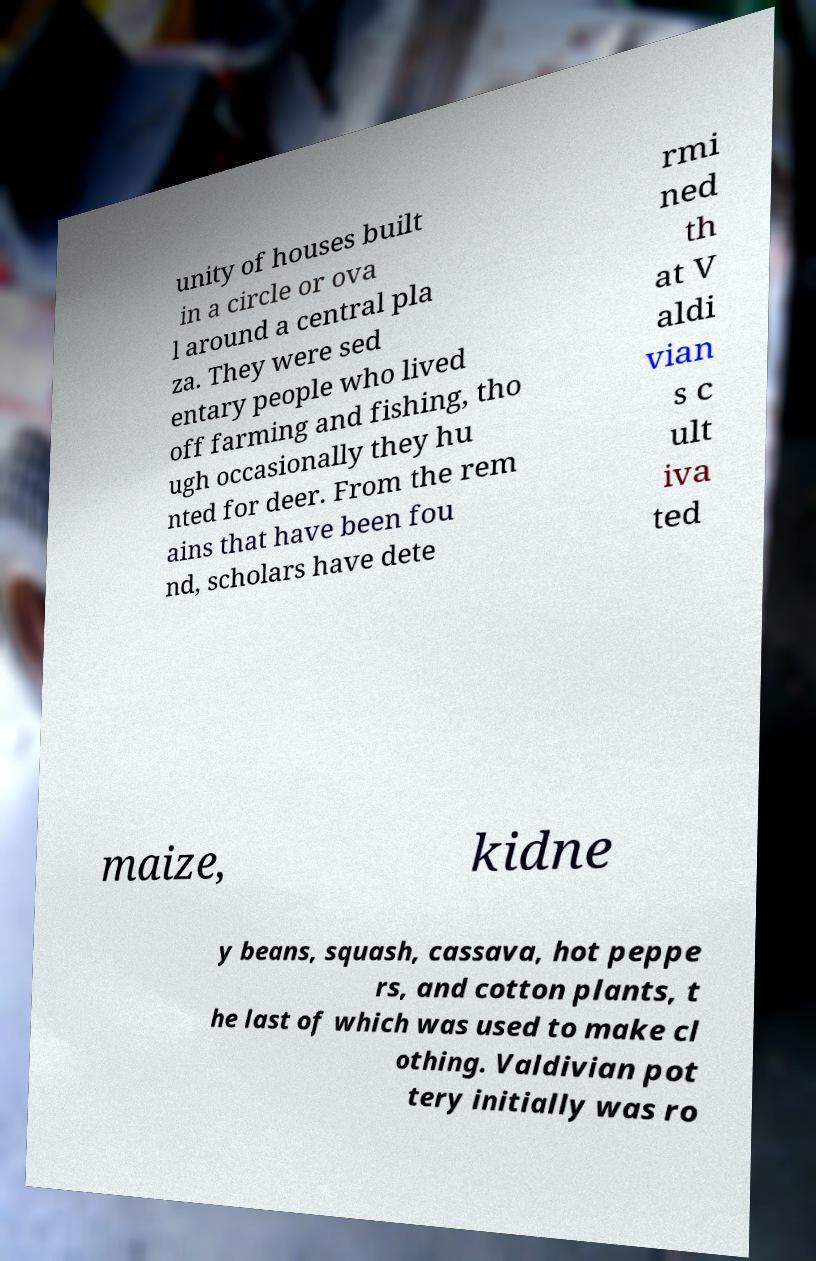What messages or text are displayed in this image? I need them in a readable, typed format. unity of houses built in a circle or ova l around a central pla za. They were sed entary people who lived off farming and fishing, tho ugh occasionally they hu nted for deer. From the rem ains that have been fou nd, scholars have dete rmi ned th at V aldi vian s c ult iva ted maize, kidne y beans, squash, cassava, hot peppe rs, and cotton plants, t he last of which was used to make cl othing. Valdivian pot tery initially was ro 